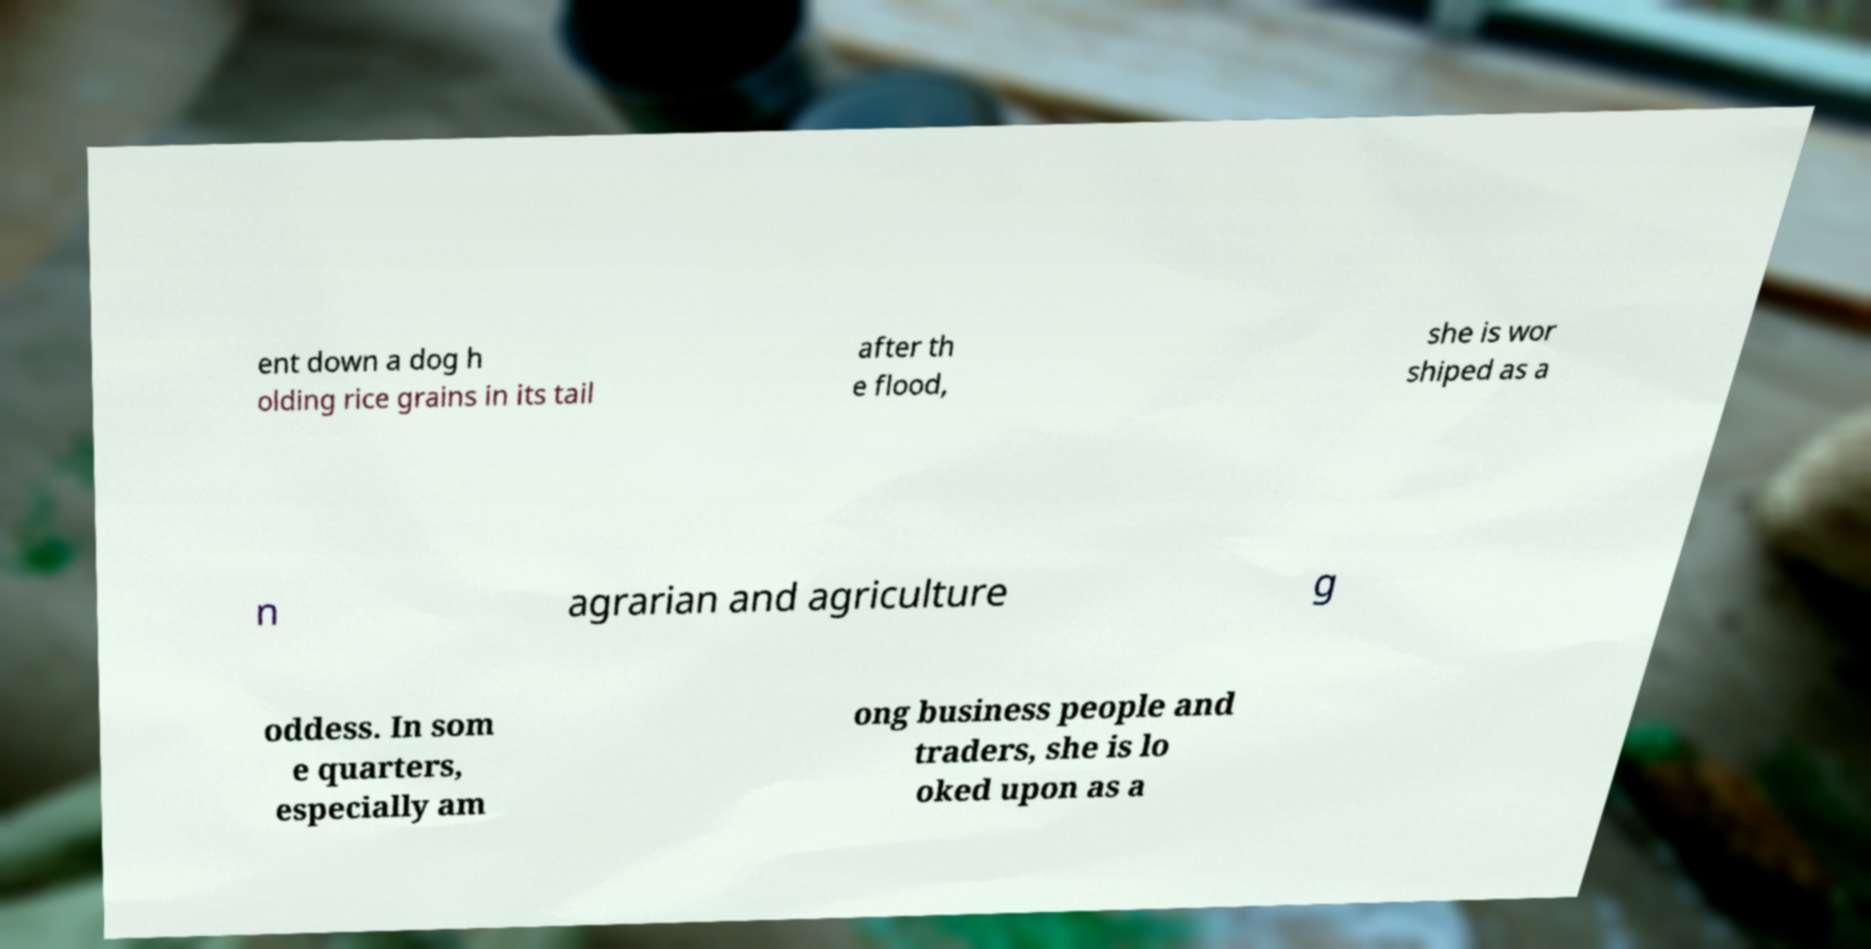Could you extract and type out the text from this image? ent down a dog h olding rice grains in its tail after th e flood, she is wor shiped as a n agrarian and agriculture g oddess. In som e quarters, especially am ong business people and traders, she is lo oked upon as a 